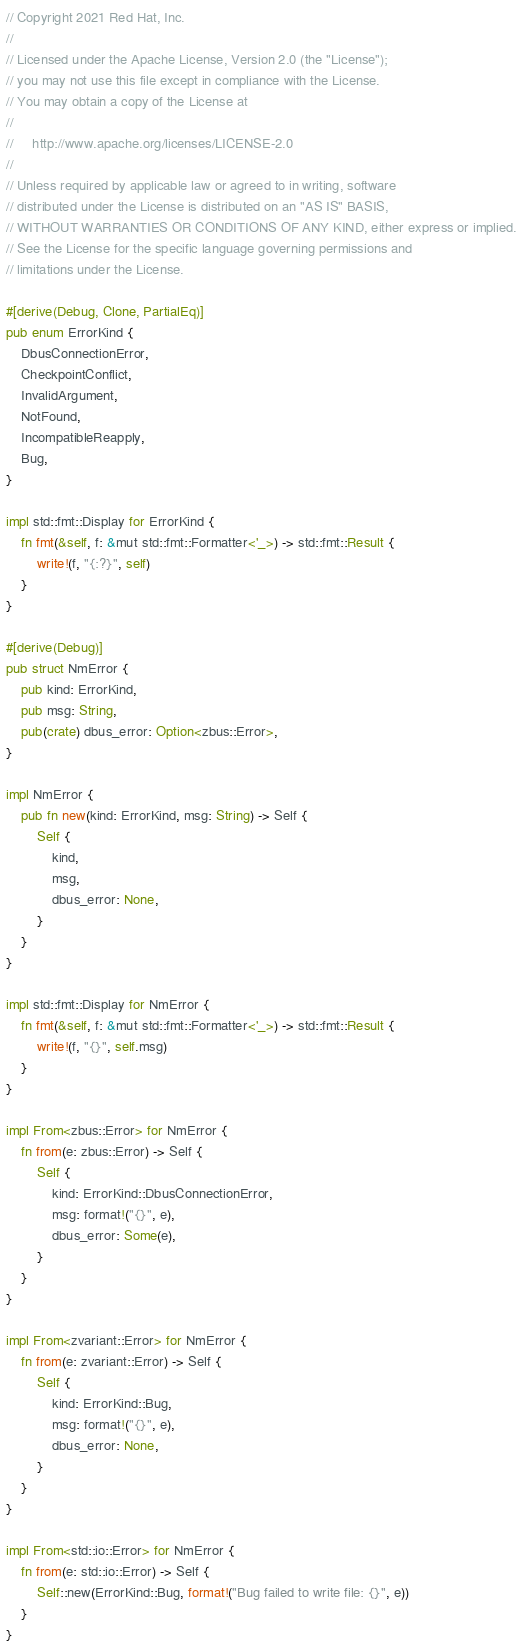<code> <loc_0><loc_0><loc_500><loc_500><_Rust_>// Copyright 2021 Red Hat, Inc.
//
// Licensed under the Apache License, Version 2.0 (the "License");
// you may not use this file except in compliance with the License.
// You may obtain a copy of the License at
//
//     http://www.apache.org/licenses/LICENSE-2.0
//
// Unless required by applicable law or agreed to in writing, software
// distributed under the License is distributed on an "AS IS" BASIS,
// WITHOUT WARRANTIES OR CONDITIONS OF ANY KIND, either express or implied.
// See the License for the specific language governing permissions and
// limitations under the License.

#[derive(Debug, Clone, PartialEq)]
pub enum ErrorKind {
    DbusConnectionError,
    CheckpointConflict,
    InvalidArgument,
    NotFound,
    IncompatibleReapply,
    Bug,
}

impl std::fmt::Display for ErrorKind {
    fn fmt(&self, f: &mut std::fmt::Formatter<'_>) -> std::fmt::Result {
        write!(f, "{:?}", self)
    }
}

#[derive(Debug)]
pub struct NmError {
    pub kind: ErrorKind,
    pub msg: String,
    pub(crate) dbus_error: Option<zbus::Error>,
}

impl NmError {
    pub fn new(kind: ErrorKind, msg: String) -> Self {
        Self {
            kind,
            msg,
            dbus_error: None,
        }
    }
}

impl std::fmt::Display for NmError {
    fn fmt(&self, f: &mut std::fmt::Formatter<'_>) -> std::fmt::Result {
        write!(f, "{}", self.msg)
    }
}

impl From<zbus::Error> for NmError {
    fn from(e: zbus::Error) -> Self {
        Self {
            kind: ErrorKind::DbusConnectionError,
            msg: format!("{}", e),
            dbus_error: Some(e),
        }
    }
}

impl From<zvariant::Error> for NmError {
    fn from(e: zvariant::Error) -> Self {
        Self {
            kind: ErrorKind::Bug,
            msg: format!("{}", e),
            dbus_error: None,
        }
    }
}

impl From<std::io::Error> for NmError {
    fn from(e: std::io::Error) -> Self {
        Self::new(ErrorKind::Bug, format!("Bug failed to write file: {}", e))
    }
}
</code> 